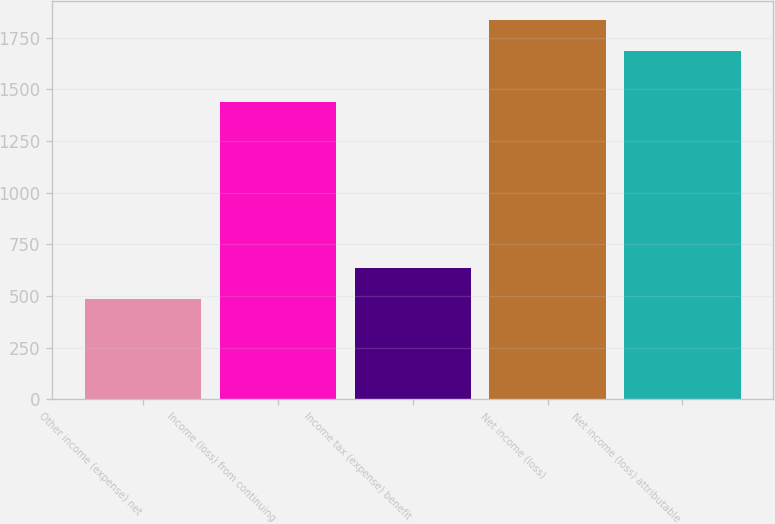<chart> <loc_0><loc_0><loc_500><loc_500><bar_chart><fcel>Other income (expense) net<fcel>Income (loss) from continuing<fcel>Income tax (expense) benefit<fcel>Net income (loss)<fcel>Net income (loss) attributable<nl><fcel>486<fcel>1437<fcel>636.5<fcel>1837.5<fcel>1687<nl></chart> 